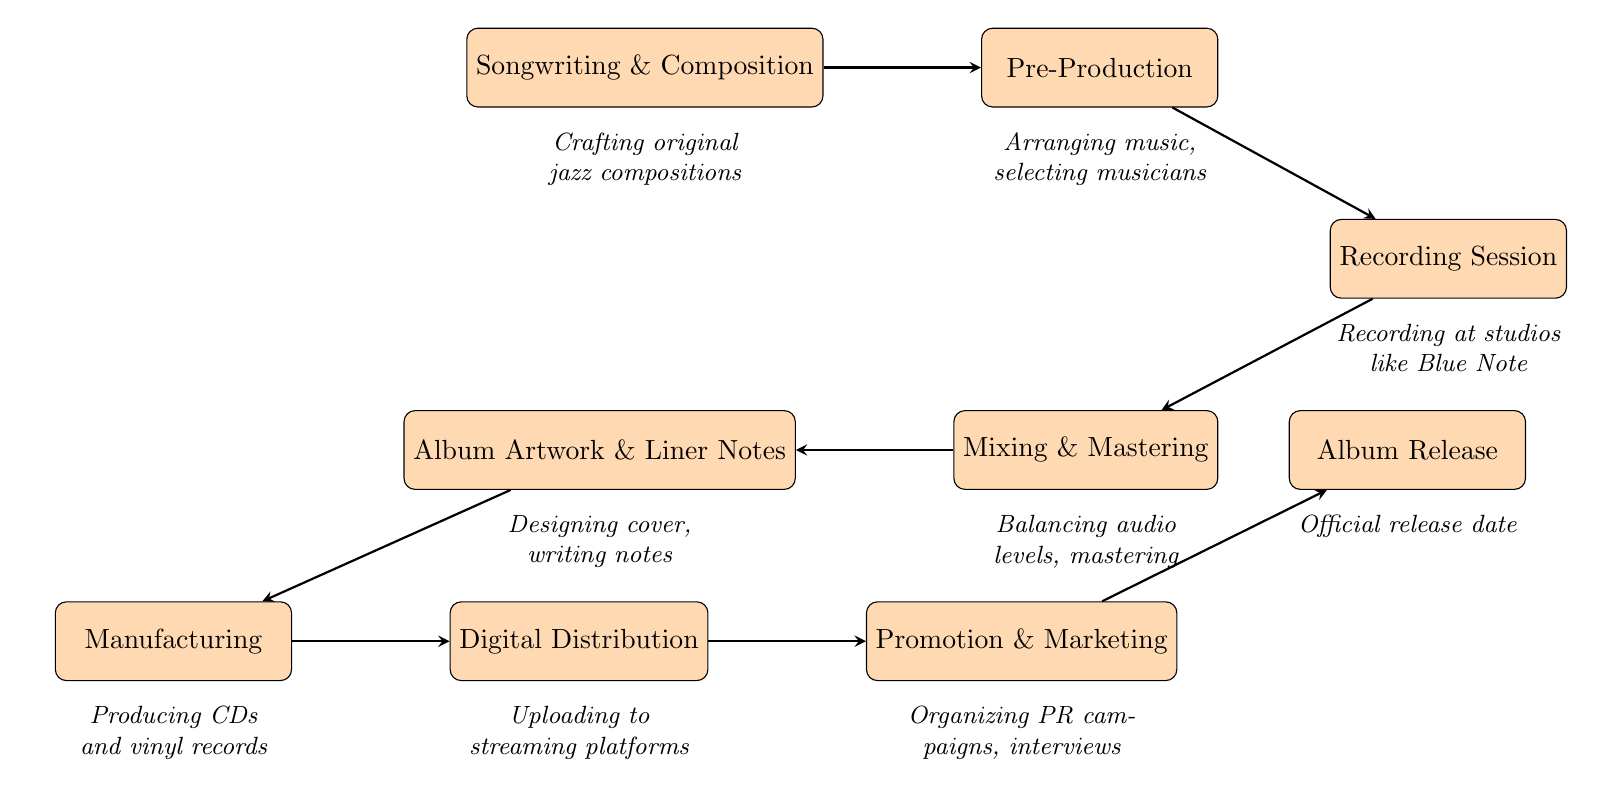What is the first step in the record release process? The flow chart starts with the node labeled "Songwriting & Composition," indicating that this is the initial step in the process.
Answer: Songwriting & Composition How many nodes are in the diagram? By counting the individual processes represented in the flow chart, we find there are nine distinct nodes from "Songwriting & Composition" to "Album Release."
Answer: 9 What is the last step before the Album Release? The last step before the "Album Release" is the node for "Promotion & Marketing," indicating that all promotional activities culminate just before the release.
Answer: Promotion & Marketing Which step comes after Mixing & Mastering? According to the arrows connecting the nodes, "Album Artwork & Liner Notes" follows "Mixing & Mastering," showing that design and notes come next.
Answer: Album Artwork & Liner Notes What is the relationship between Digital Distribution and Album Release? The diagram shows an arrow from "Digital Distribution" to "Promotion & Marketing," which then leads to "Album Release," establishing a sequential relationship where distribution prepares for promotion before release.
Answer: Sequential relationship 